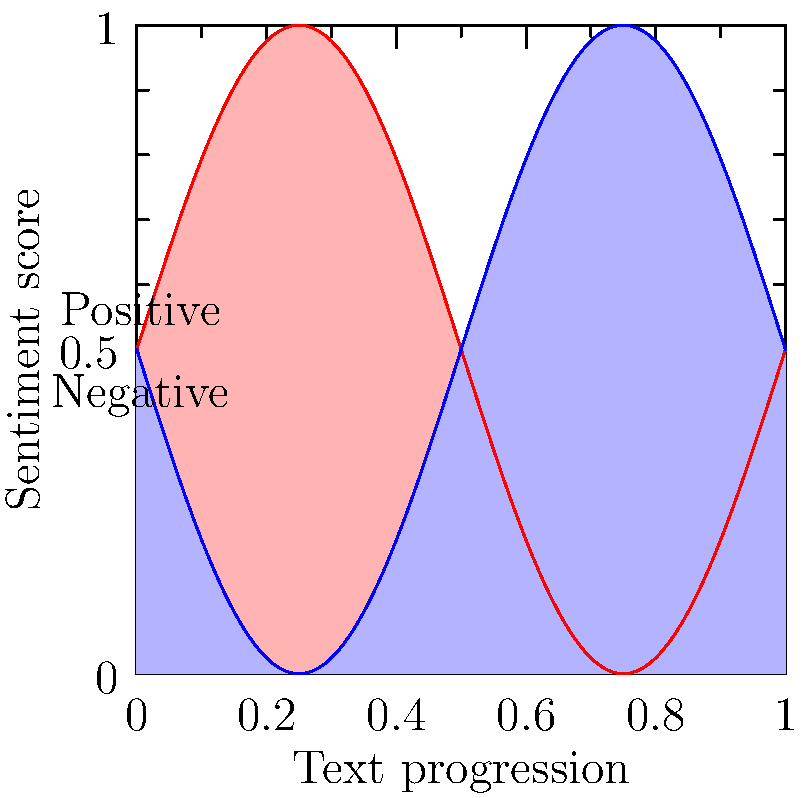Analyze the heat map representation of sentiment analysis for a Renaissance text. The x-axis represents the progression of the text, and the y-axis represents the sentiment score. Red areas indicate positive sentiment, while blue areas indicate negative sentiment. What can be inferred about the overall emotional tone of the text, and how might this visualization technique be useful in comparing multiple Renaissance works? 1. Interpret the heat map:
   - The x-axis represents the progression of the text from beginning to end.
   - The y-axis represents the sentiment score, with higher values indicating more positive sentiment.
   - Red areas correspond to positive sentiment, while blue areas correspond to negative sentiment.

2. Analyze the pattern:
   - The sentiment oscillates between positive and negative throughout the text.
   - The oscillation appears to be regular, suggesting a consistent emotional rhythm in the work.

3. Calculate the overall sentiment:
   - The areas of red and blue seem roughly equal.
   - This suggests a balanced emotional tone throughout the text.

4. Consider the usefulness of this visualization:
   - It provides a quick, visual summary of the emotional content of the text.
   - Patterns and trends in sentiment can be easily identified.
   - Multiple texts could be compared side-by-side to identify similarities or differences in emotional structure.

5. Application to Renaissance literature:
   - This technique could be used to compare the emotional arcs of different authors or genres.
   - It could help identify characteristic patterns in Renaissance writing styles.
   - Researchers could use it to study how emotional content relates to narrative structure in Renaissance texts.

6. Machine learning implications:
   - This visualization is likely the output of a sentiment analysis algorithm.
   - The algorithm would need to be trained on Renaissance-specific language and context.
   - The regular pattern suggests the algorithm might be oversimplifying complex emotional content.
Answer: The text shows a balanced, oscillating emotional tone. This visualization enables quick comparison of emotional structures across multiple Renaissance works, aiding in the study of authorial styles and narrative patterns. 